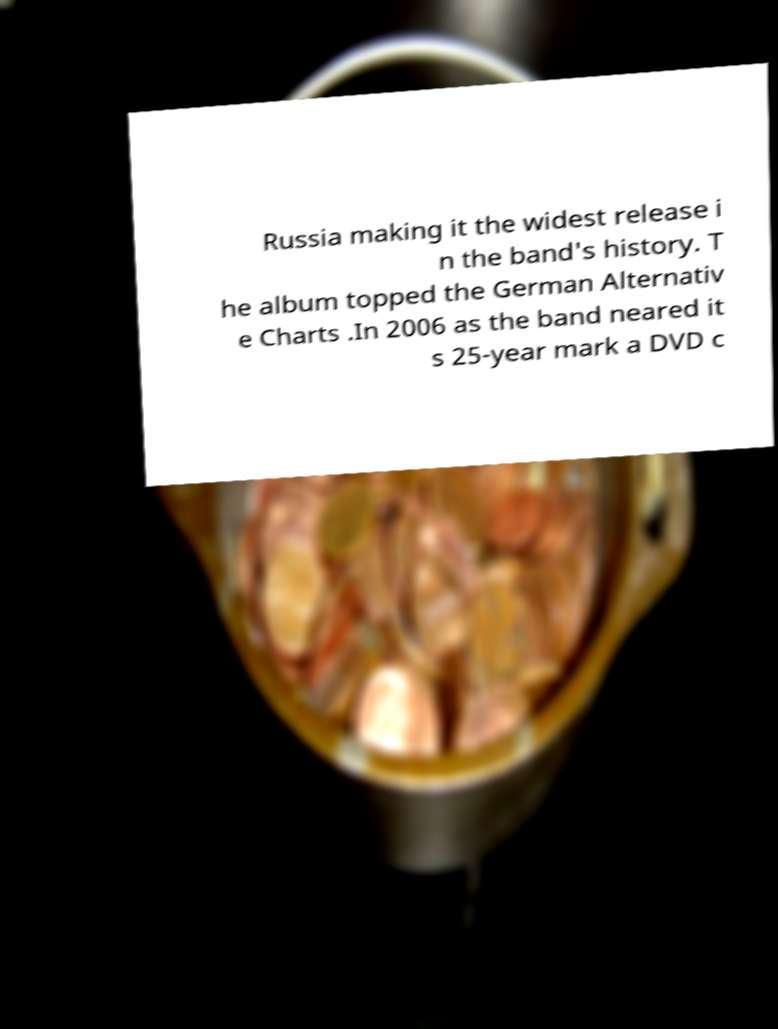Could you extract and type out the text from this image? Russia making it the widest release i n the band's history. T he album topped the German Alternativ e Charts .In 2006 as the band neared it s 25-year mark a DVD c 